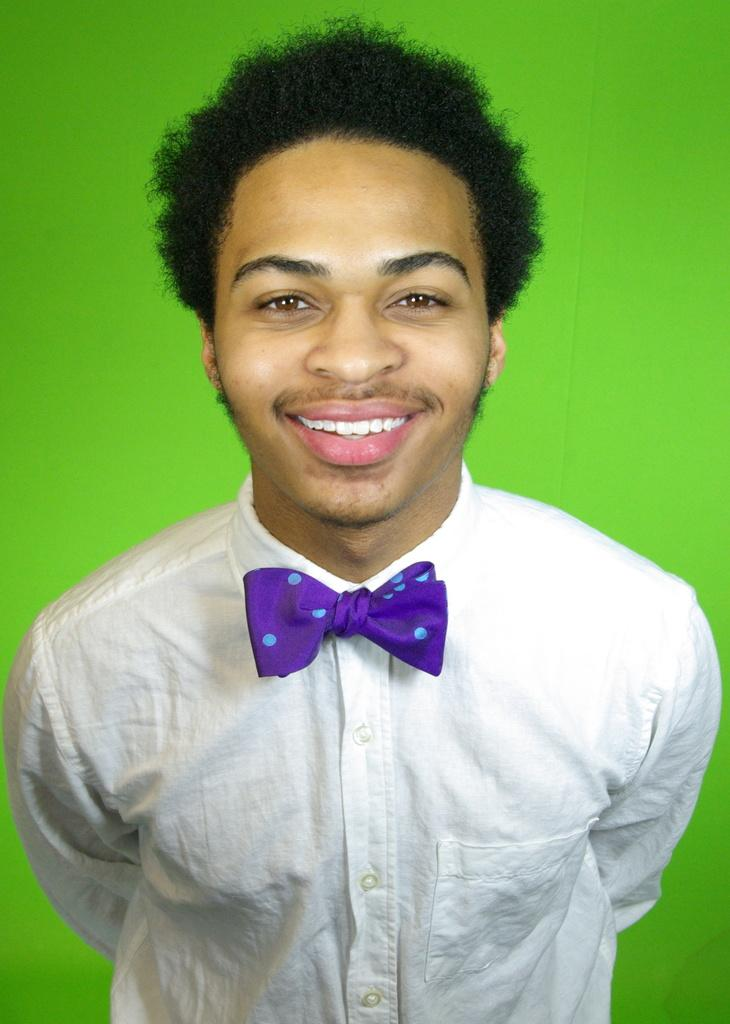What is the main subject of the image? There is a man in the image. What is the man wearing on his upper body? The man is wearing a white shirt. What type of accessory is the man wearing around his neck? The man is wearing a purple bow tie. Where is the man positioned in the image? The man is standing in the front. What expression does the man have on his face? The man is smiling. What can be seen in the background of the image? There is a green screen in the background. What type of tramp can be seen jumping in the image? There is no tramp present in the image; it features a man wearing a white shirt and a purple bow tie. Is the man holding a gun in the image? No, the man is not holding a gun in the image. 